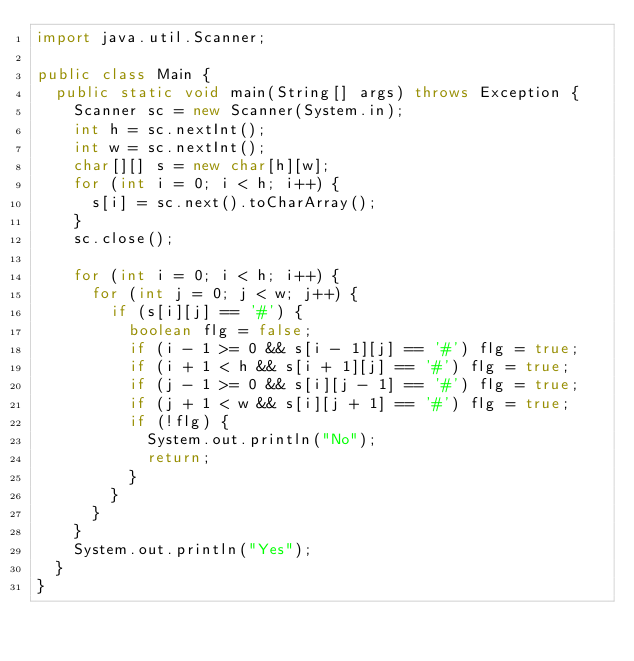Convert code to text. <code><loc_0><loc_0><loc_500><loc_500><_Java_>import java.util.Scanner;

public class Main {
	public static void main(String[] args) throws Exception {
		Scanner sc = new Scanner(System.in);
		int h = sc.nextInt();
		int w = sc.nextInt();
		char[][] s = new char[h][w];
		for (int i = 0; i < h; i++) {
			s[i] = sc.next().toCharArray();
		}
		sc.close();

		for (int i = 0; i < h; i++) {
			for (int j = 0; j < w; j++) {
				if (s[i][j] == '#') {
					boolean flg = false;
					if (i - 1 >= 0 && s[i - 1][j] == '#') flg = true;
					if (i + 1 < h && s[i + 1][j] == '#') flg = true;
					if (j - 1 >= 0 && s[i][j - 1] == '#') flg = true;
					if (j + 1 < w && s[i][j + 1] == '#') flg = true;
					if (!flg) {
						System.out.println("No");
						return;
					}
				}
			}
		}
		System.out.println("Yes");
	}
}
</code> 